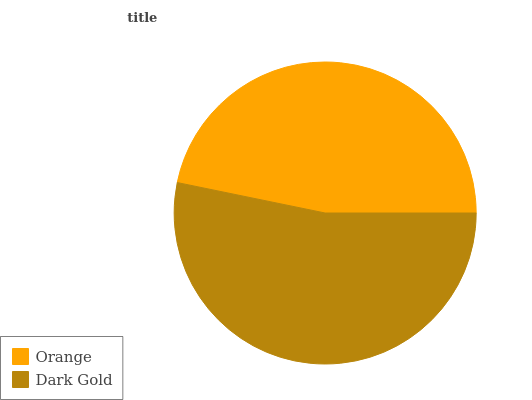Is Orange the minimum?
Answer yes or no. Yes. Is Dark Gold the maximum?
Answer yes or no. Yes. Is Dark Gold the minimum?
Answer yes or no. No. Is Dark Gold greater than Orange?
Answer yes or no. Yes. Is Orange less than Dark Gold?
Answer yes or no. Yes. Is Orange greater than Dark Gold?
Answer yes or no. No. Is Dark Gold less than Orange?
Answer yes or no. No. Is Dark Gold the high median?
Answer yes or no. Yes. Is Orange the low median?
Answer yes or no. Yes. Is Orange the high median?
Answer yes or no. No. Is Dark Gold the low median?
Answer yes or no. No. 